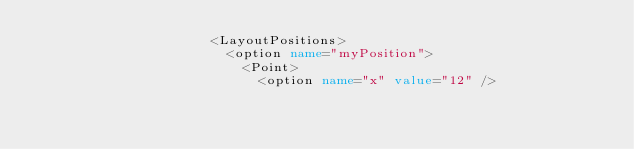Convert code to text. <code><loc_0><loc_0><loc_500><loc_500><_XML_>                      <LayoutPositions>
                        <option name="myPosition">
                          <Point>
                            <option name="x" value="12" /></code> 